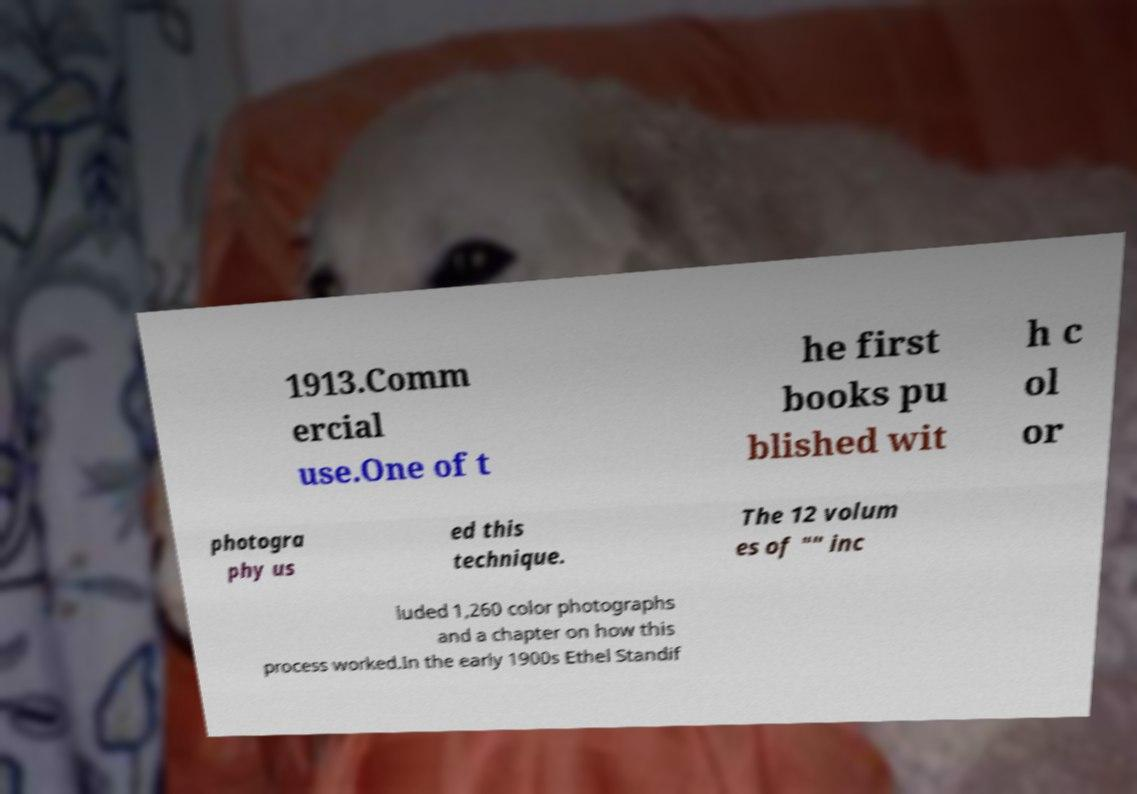Please read and relay the text visible in this image. What does it say? 1913.Comm ercial use.One of t he first books pu blished wit h c ol or photogra phy us ed this technique. The 12 volum es of "" inc luded 1,260 color photographs and a chapter on how this process worked.In the early 1900s Ethel Standif 